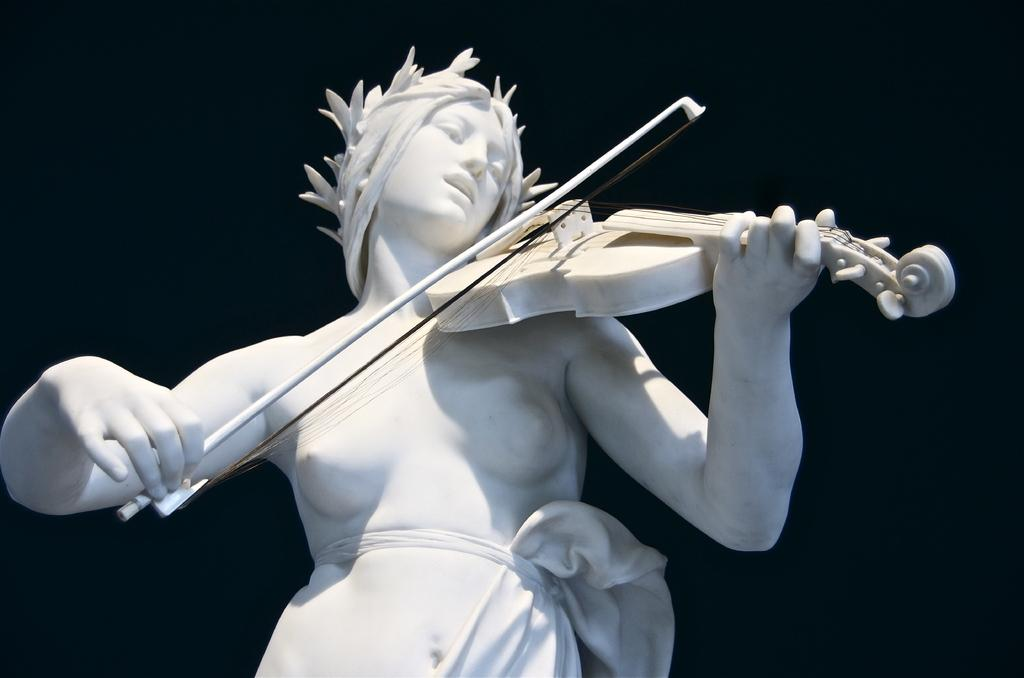What is the main subject in the center of the image? There is a statue in the center of the image. What is the statue holding? The statue is holding a violin. What can be observed about the background of the image? The background of the image is dark. What type of polish is the statue applying to the violin in the image? There is no indication in the image that the statue is applying any polish to the violin. 